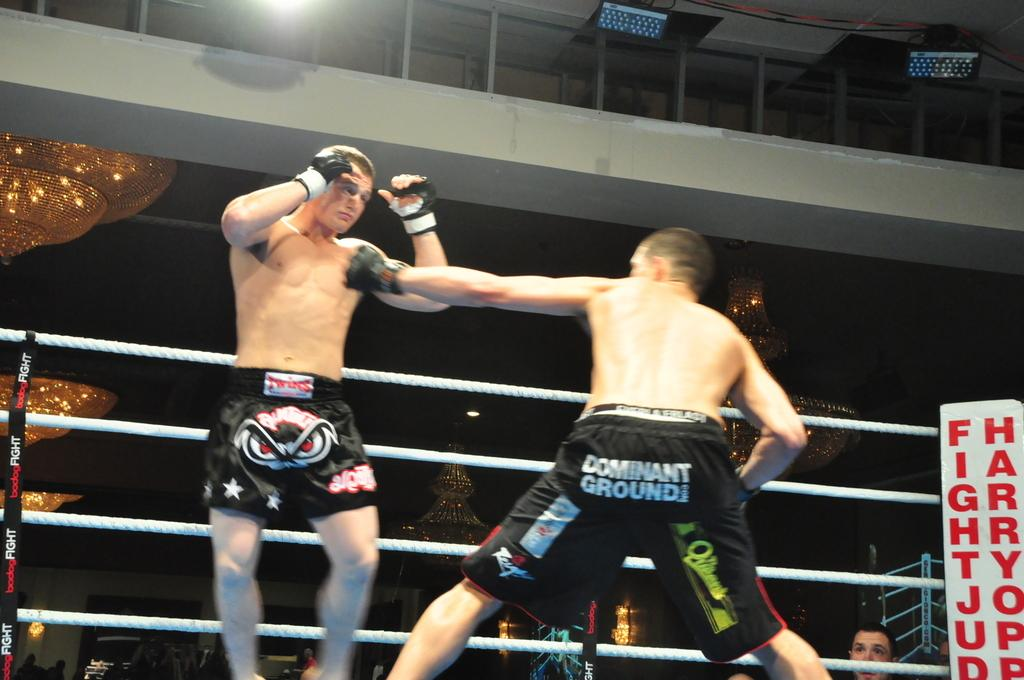Provide a one-sentence caption for the provided image. Two men boxing with one man wearing shorts that says "Dominant Ground". 